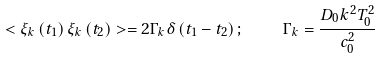<formula> <loc_0><loc_0><loc_500><loc_500>< \xi _ { k } \left ( t _ { 1 } \right ) \xi _ { k } \left ( t _ { 2 } \right ) > = 2 \Gamma _ { k } \delta \left ( t _ { 1 } - t _ { 2 } \right ) ; \quad \Gamma _ { k } = \frac { D _ { 0 } k ^ { 2 } T _ { 0 } ^ { 2 } } { c _ { 0 } ^ { 2 } }</formula> 